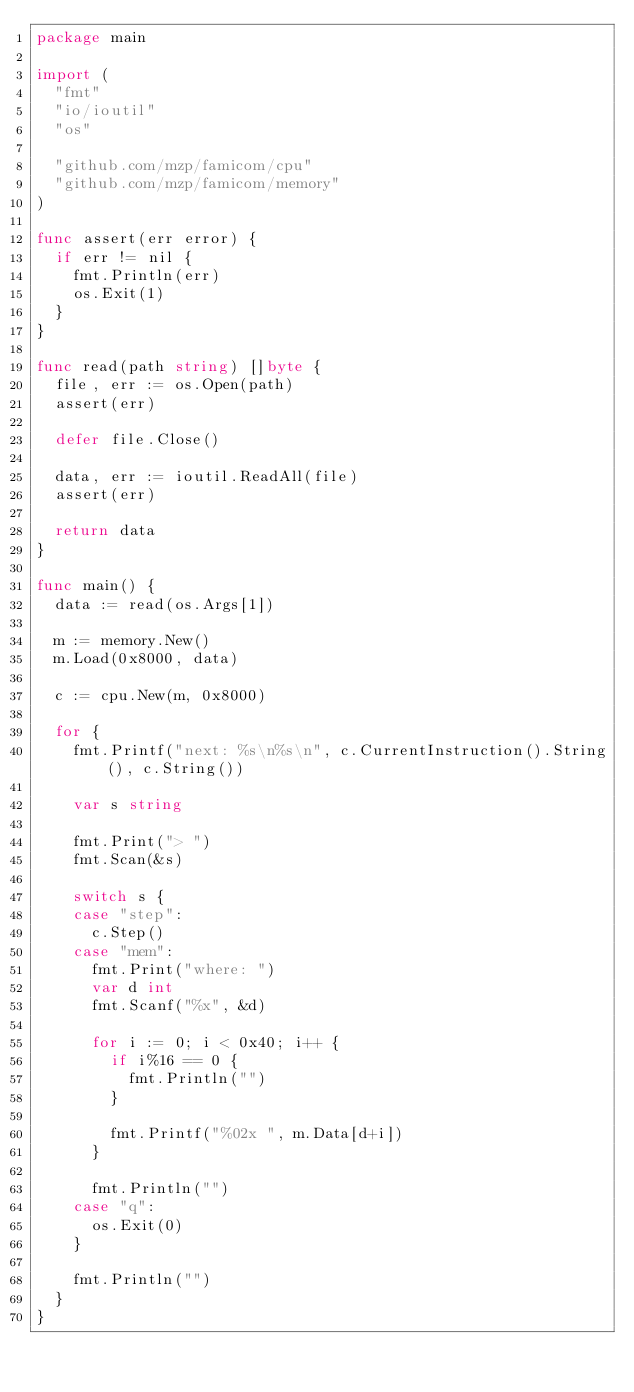Convert code to text. <code><loc_0><loc_0><loc_500><loc_500><_Go_>package main

import (
	"fmt"
	"io/ioutil"
	"os"

	"github.com/mzp/famicom/cpu"
	"github.com/mzp/famicom/memory"
)

func assert(err error) {
	if err != nil {
		fmt.Println(err)
		os.Exit(1)
	}
}

func read(path string) []byte {
	file, err := os.Open(path)
	assert(err)

	defer file.Close()

	data, err := ioutil.ReadAll(file)
	assert(err)

	return data
}

func main() {
	data := read(os.Args[1])

	m := memory.New()
	m.Load(0x8000, data)

	c := cpu.New(m, 0x8000)

	for {
		fmt.Printf("next: %s\n%s\n", c.CurrentInstruction().String(), c.String())

		var s string

		fmt.Print("> ")
		fmt.Scan(&s)

		switch s {
		case "step":
			c.Step()
		case "mem":
			fmt.Print("where: ")
			var d int
			fmt.Scanf("%x", &d)

			for i := 0; i < 0x40; i++ {
				if i%16 == 0 {
					fmt.Println("")
				}

				fmt.Printf("%02x ", m.Data[d+i])
			}

			fmt.Println("")
		case "q":
			os.Exit(0)
		}

		fmt.Println("")
	}
}
</code> 